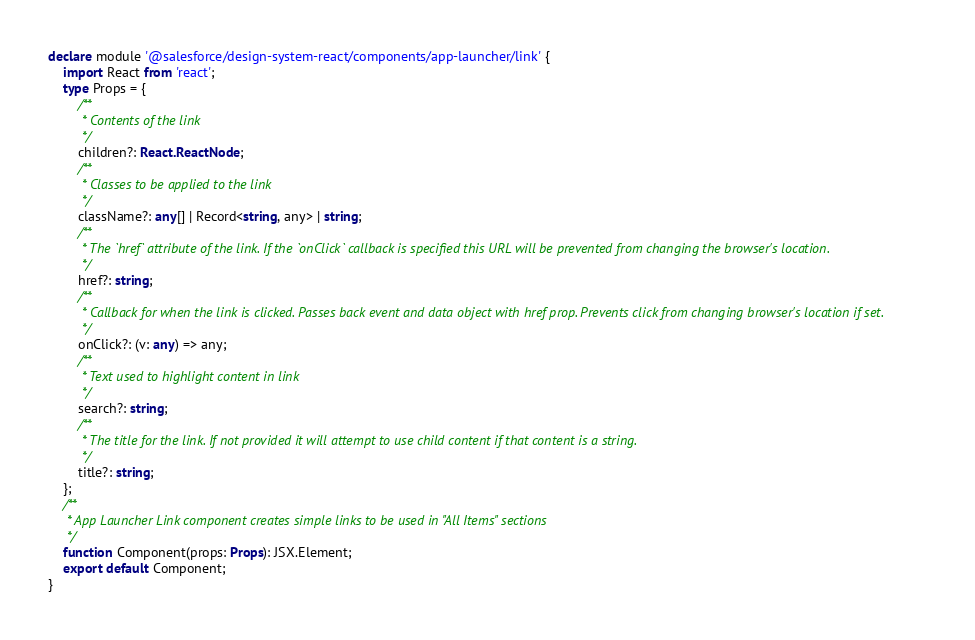Convert code to text. <code><loc_0><loc_0><loc_500><loc_500><_TypeScript_>declare module '@salesforce/design-system-react/components/app-launcher/link' {
	import React from 'react';
	type Props = {
		/**
		 * Contents of the link
		 */
		children?: React.ReactNode;
		/**
		 * Classes to be applied to the link
		 */
		className?: any[] | Record<string, any> | string;
		/**
		 * The `href` attribute of the link. If the `onClick` callback is specified this URL will be prevented from changing the browser's location.
		 */
		href?: string;
		/**
		 * Callback for when the link is clicked. Passes back event and data object with href prop. Prevents click from changing browser's location if set.
		 */
		onClick?: (v: any) => any;
		/**
		 * Text used to highlight content in link
		 */
		search?: string;
		/**
		 * The title for the link. If not provided it will attempt to use child content if that content is a string.
		 */
		title?: string;
	};
	/**
	 * App Launcher Link component creates simple links to be used in "All Items" sections
	 */
	function Component(props: Props): JSX.Element;
	export default Component;
}
</code> 